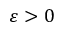<formula> <loc_0><loc_0><loc_500><loc_500>\varepsilon > 0</formula> 